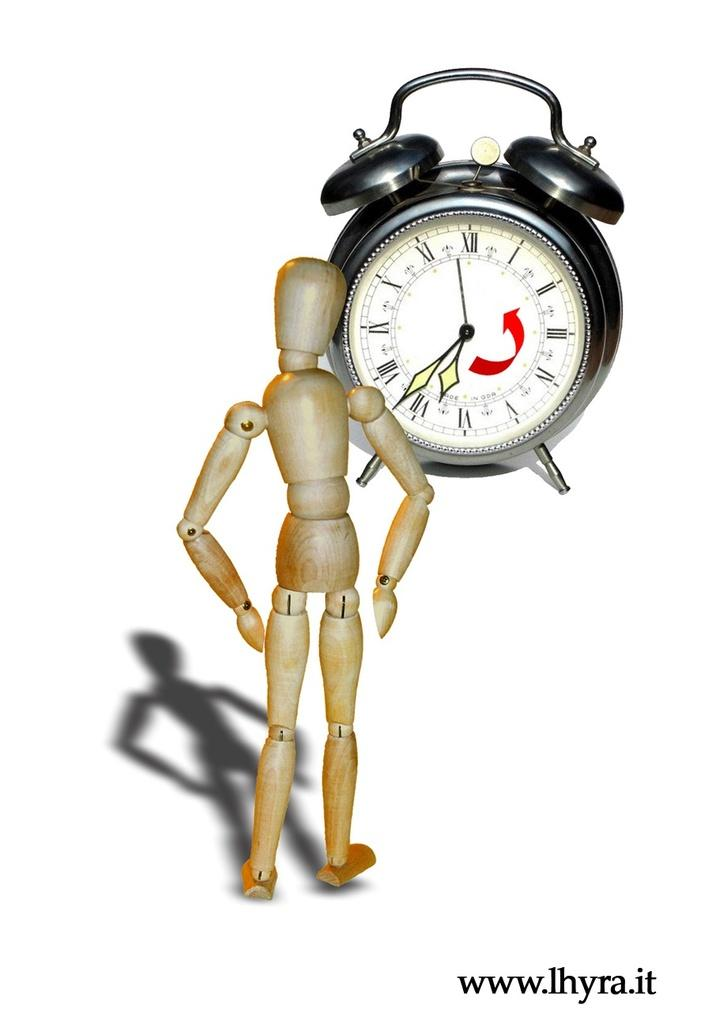<image>
Describe the image concisely. A picture of a doll in front of a clock, with an address to the website www.ihyra.it 